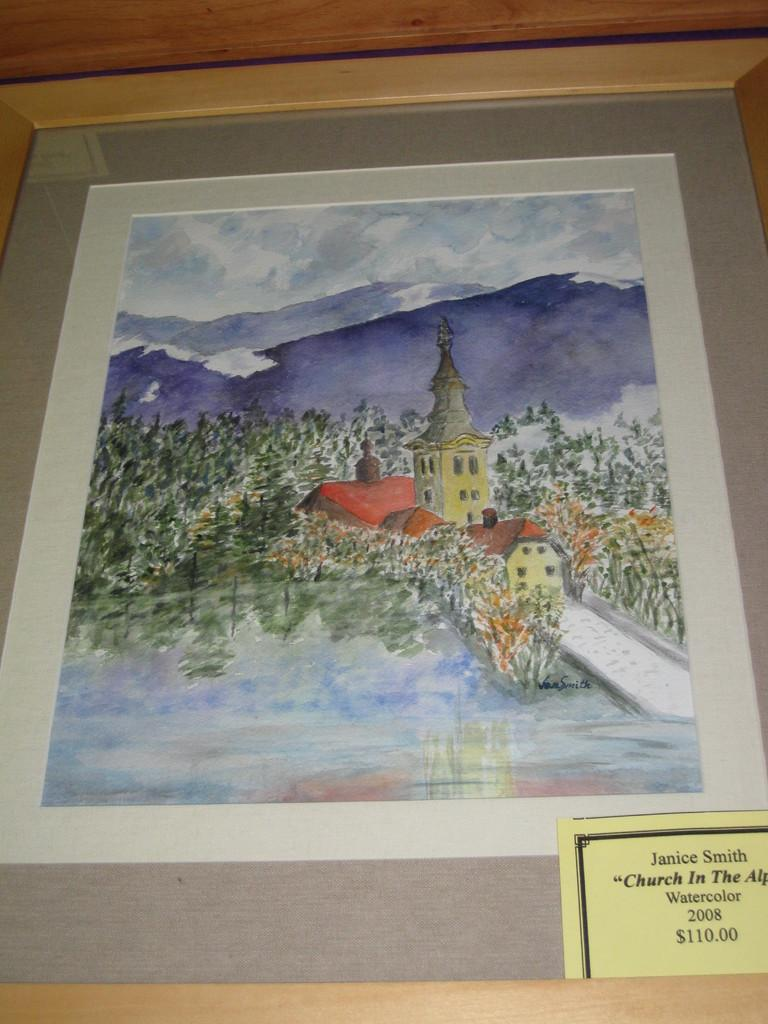Provide a one-sentence caption for the provided image. Picture of a church that Janice Smith made using watercolor  called Church In the. 